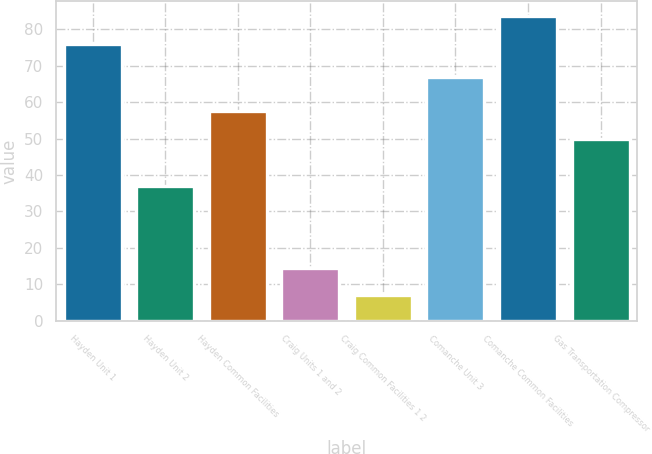<chart> <loc_0><loc_0><loc_500><loc_500><bar_chart><fcel>Hayden Unit 1<fcel>Hayden Unit 2<fcel>Hayden Common Facilities<fcel>Craig Units 1 and 2<fcel>Craig Common Facilities 1 2<fcel>Comanche Unit 3<fcel>Comanche Common Facilities<fcel>Gas Transportation Compressor<nl><fcel>76<fcel>37<fcel>57.5<fcel>14.5<fcel>7<fcel>67<fcel>83.5<fcel>50<nl></chart> 